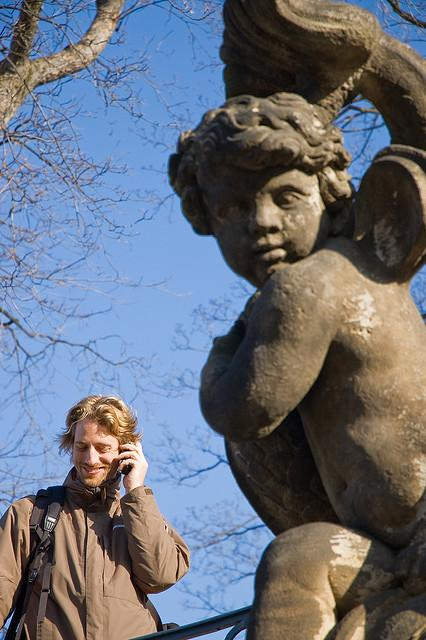What is the grey statue supposed to be? Please explain your reasoning. angel. It resembles that of a well known figure depicted in renessaince art of an angel baby or cherub. 